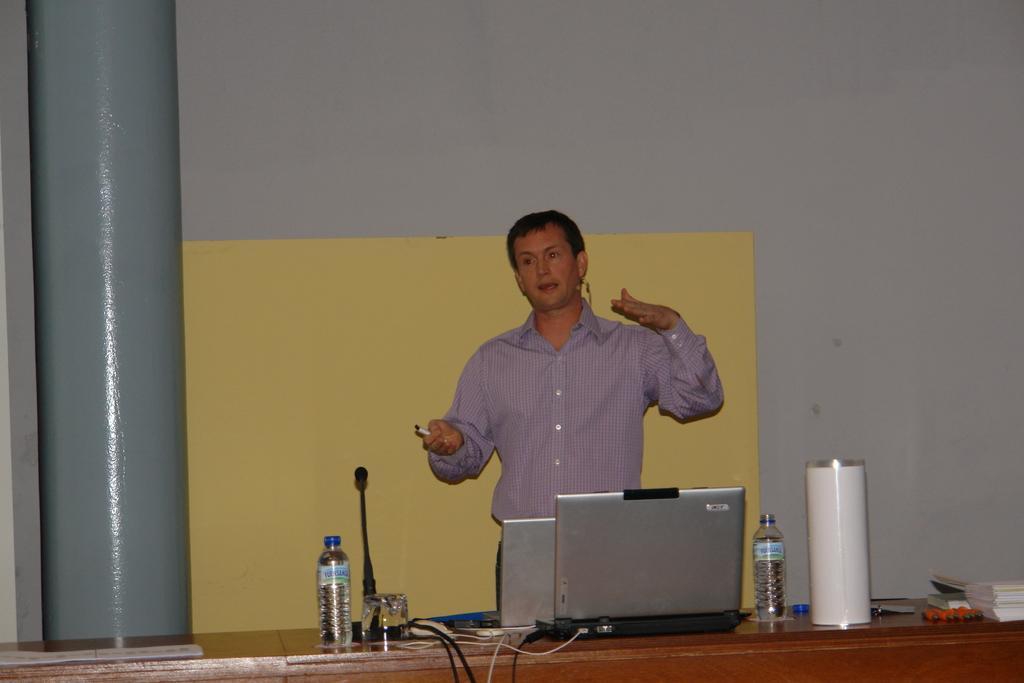Could you give a brief overview of what you see in this image? In this image there is a table having laptops, bottles, books, mike, glass and few objects. Behind the table there is a person standing. He is holding a pen. Behind him there is a board. Left side there is a pillar. Background there is a wall. 